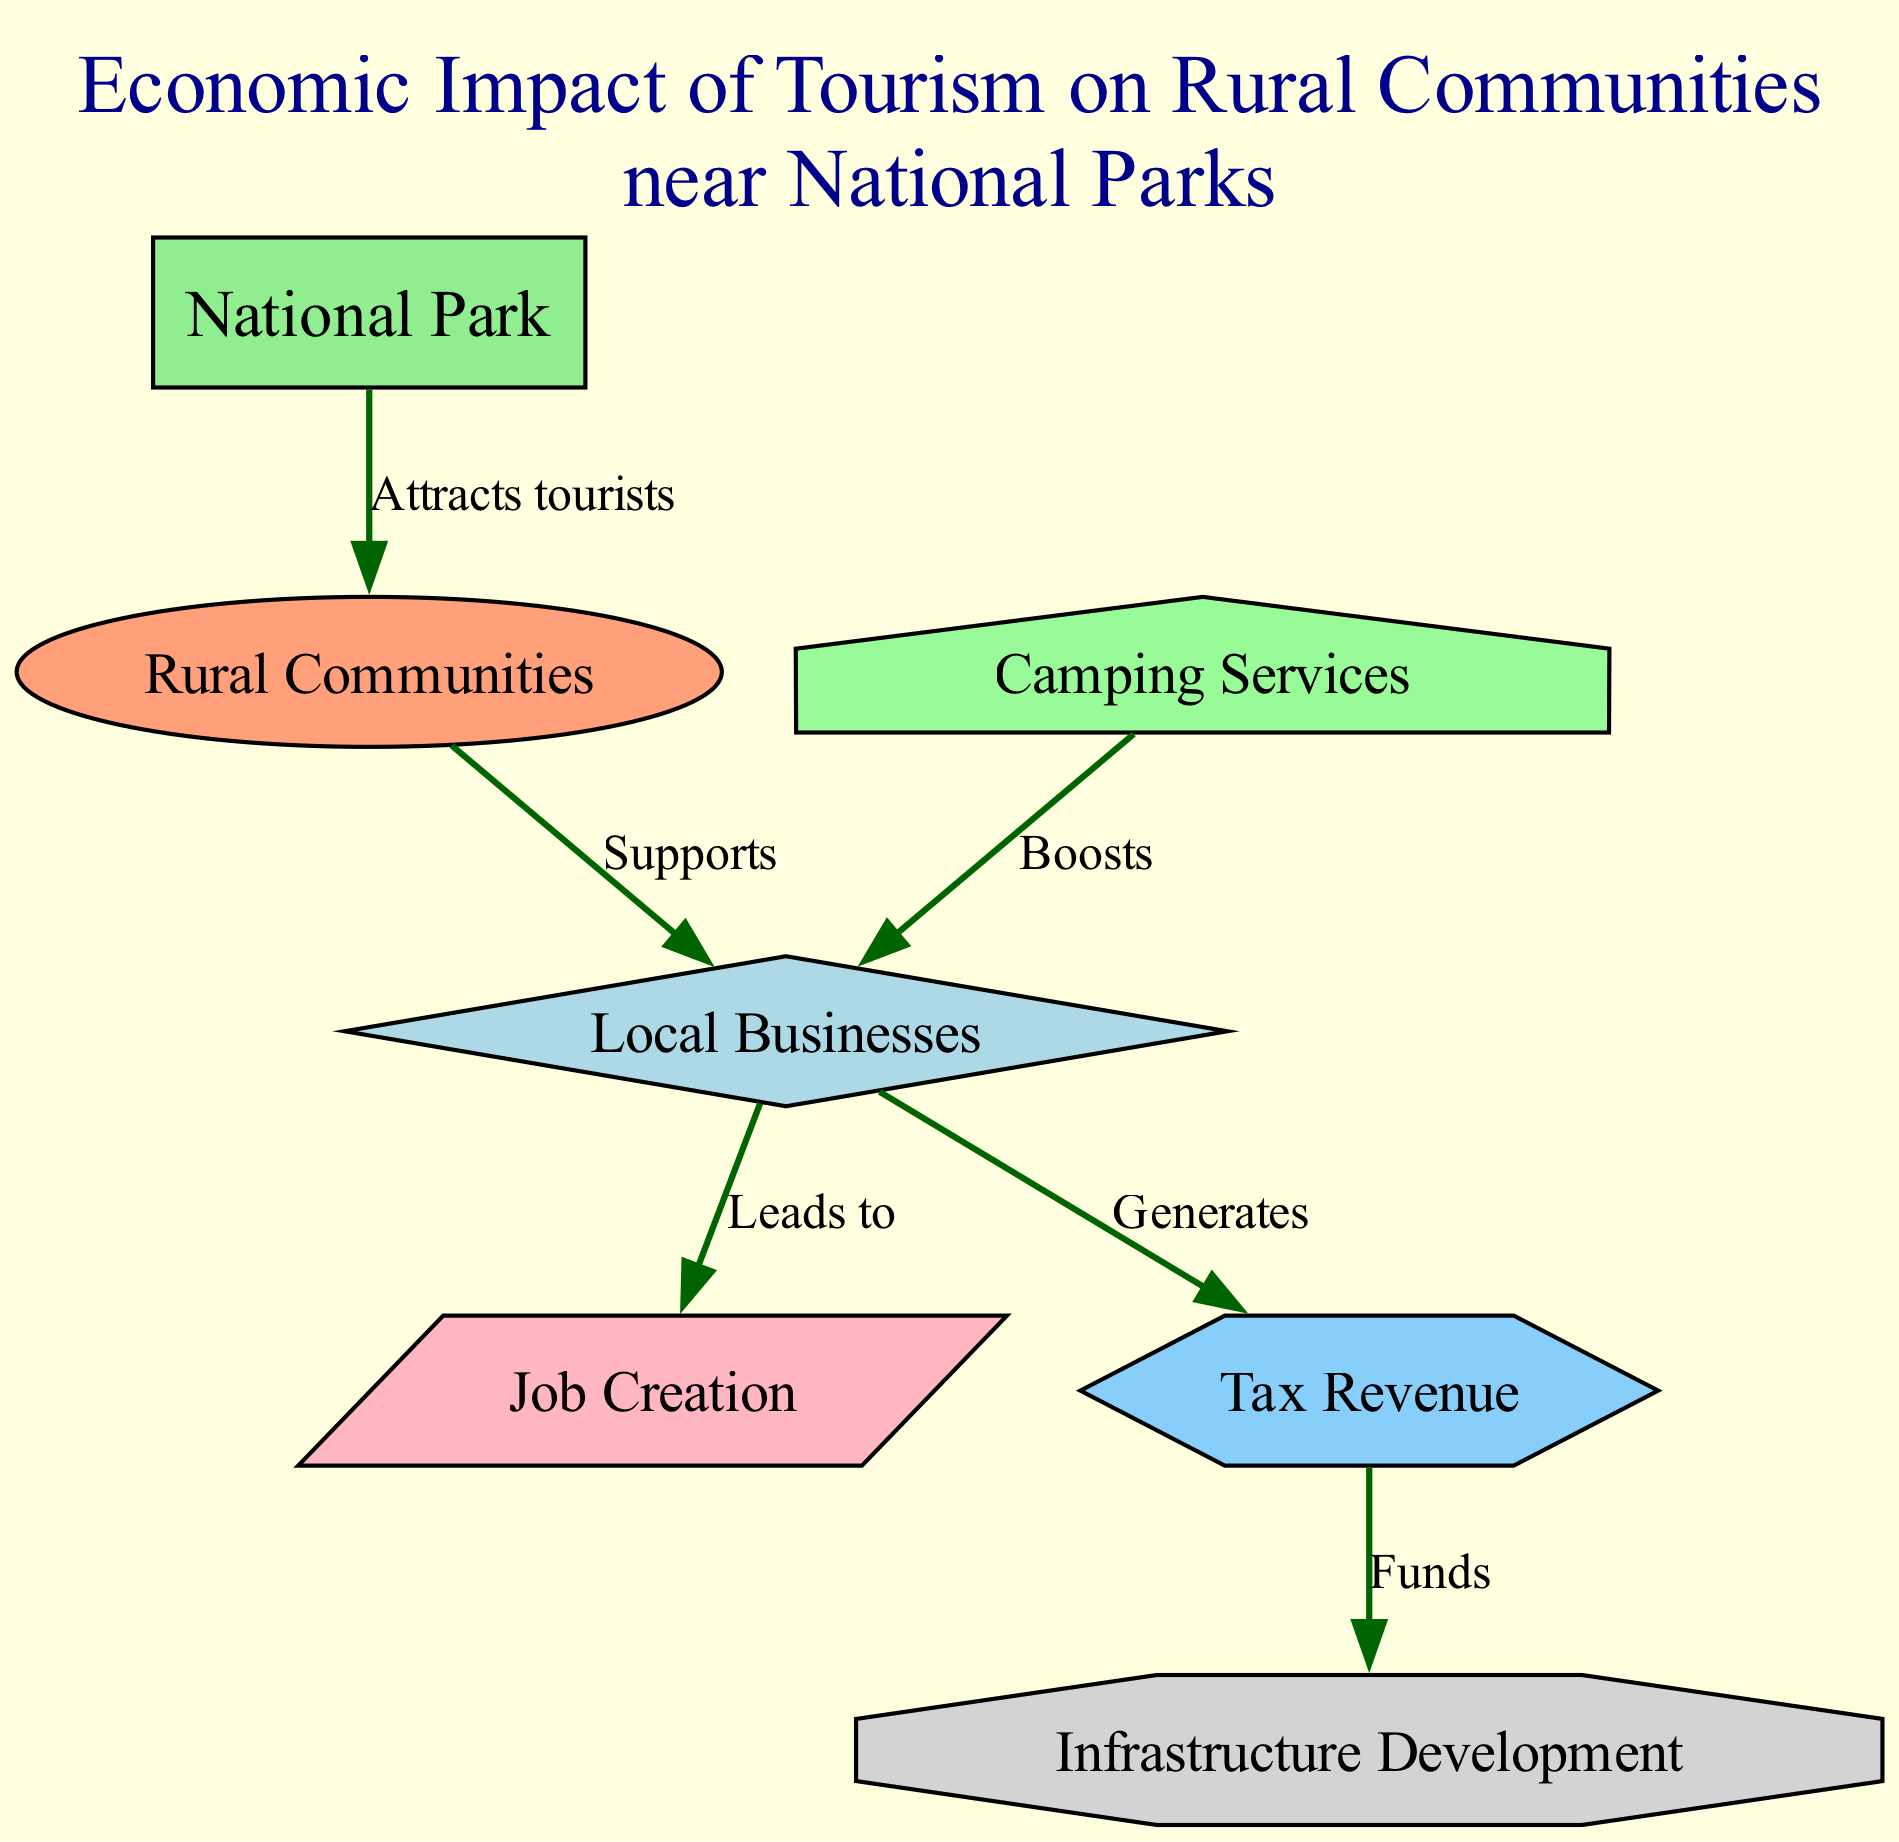what is the number of nodes in the diagram? The diagram has 7 nodes listed under the "nodes" section of the data. Each node represents a distinct element related to the economic impact of tourism.
Answer: 7 what does the National Park attract? The arrow connecting the "National Park" to "Rural Communities" indicates that the National Park attracts tourists. This is explicitly labeled as such in the diagram.
Answer: tourists which element generates tax revenue? The local businesses are shown to generate tax revenue as indicated by the edge connecting "Local Businesses" to "Tax Revenue" labeled "Generates".
Answer: Local Businesses how do camping services affect local businesses? The diagram illustrates that camping services boost local businesses as indicated by the edge from "Camping Services" to "Local Businesses" labeled "Boosts".
Answer: Boosts what funds infrastructure development? The diagram shows that tax revenue funds infrastructure development based on the edge from "Tax Revenue" to "Infrastructure Development" labeled "Funds".
Answer: Tax Revenue what leads to job creation? The connection between "Local Businesses" and "Job Creation" shows that local businesses lead to job creation, as labeled on the corresponding edge.
Answer: Local Businesses how many edges are in the diagram? The diagram lists a total of 6 edges under the "edges" section, which represent the relationships between the nodes. Each edge describes how different elements are connected.
Answer: 6 what is the shape of the node representing infrastructure development? The diagram specifies that the node representing infrastructure development has an octagon shape as indicated in the custom node styles description.
Answer: octagon which two nodes are connected by the relationship labeled "Supports"? The "Rural Communities" supports "Local Businesses", as shown by the edge labeled "Supports" connecting these two nodes in the diagram.
Answer: Rural Communities and Local Businesses 